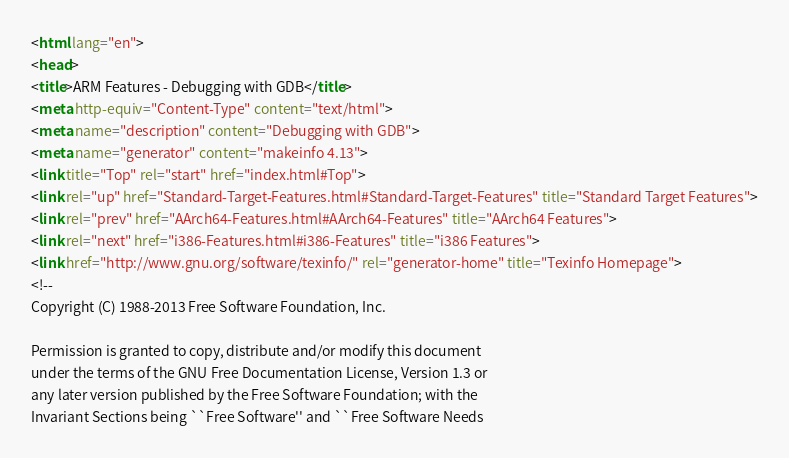Convert code to text. <code><loc_0><loc_0><loc_500><loc_500><_HTML_><html lang="en">
<head>
<title>ARM Features - Debugging with GDB</title>
<meta http-equiv="Content-Type" content="text/html">
<meta name="description" content="Debugging with GDB">
<meta name="generator" content="makeinfo 4.13">
<link title="Top" rel="start" href="index.html#Top">
<link rel="up" href="Standard-Target-Features.html#Standard-Target-Features" title="Standard Target Features">
<link rel="prev" href="AArch64-Features.html#AArch64-Features" title="AArch64 Features">
<link rel="next" href="i386-Features.html#i386-Features" title="i386 Features">
<link href="http://www.gnu.org/software/texinfo/" rel="generator-home" title="Texinfo Homepage">
<!--
Copyright (C) 1988-2013 Free Software Foundation, Inc.

Permission is granted to copy, distribute and/or modify this document
under the terms of the GNU Free Documentation License, Version 1.3 or
any later version published by the Free Software Foundation; with the
Invariant Sections being ``Free Software'' and ``Free Software Needs</code> 